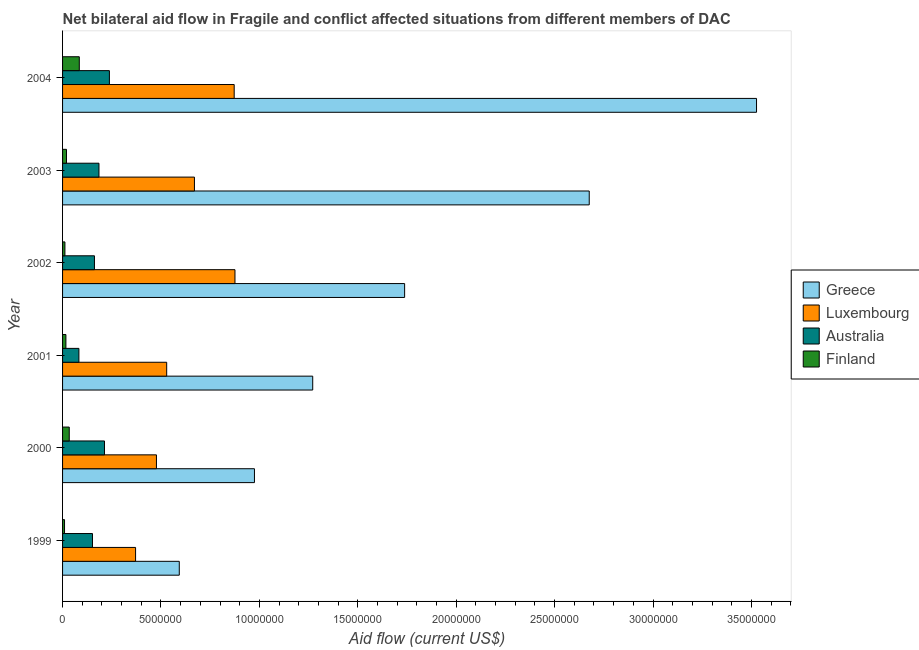How many groups of bars are there?
Offer a very short reply. 6. Are the number of bars on each tick of the Y-axis equal?
Keep it short and to the point. Yes. How many bars are there on the 1st tick from the top?
Provide a short and direct response. 4. How many bars are there on the 1st tick from the bottom?
Your answer should be compact. 4. What is the amount of aid given by australia in 2000?
Make the answer very short. 2.13e+06. Across all years, what is the maximum amount of aid given by greece?
Provide a short and direct response. 3.53e+07. Across all years, what is the minimum amount of aid given by greece?
Ensure brevity in your answer.  5.93e+06. In which year was the amount of aid given by luxembourg maximum?
Offer a very short reply. 2002. What is the total amount of aid given by greece in the graph?
Give a very brief answer. 1.08e+08. What is the difference between the amount of aid given by greece in 1999 and that in 2004?
Ensure brevity in your answer.  -2.93e+07. What is the difference between the amount of aid given by greece in 2004 and the amount of aid given by australia in 1999?
Make the answer very short. 3.37e+07. What is the average amount of aid given by greece per year?
Keep it short and to the point. 1.80e+07. In the year 1999, what is the difference between the amount of aid given by australia and amount of aid given by finland?
Provide a short and direct response. 1.42e+06. In how many years, is the amount of aid given by finland greater than 23000000 US$?
Your response must be concise. 0. What is the ratio of the amount of aid given by luxembourg in 1999 to that in 2004?
Provide a succinct answer. 0.42. What is the difference between the highest and the second highest amount of aid given by finland?
Your answer should be compact. 5.10e+05. What is the difference between the highest and the lowest amount of aid given by australia?
Your response must be concise. 1.55e+06. In how many years, is the amount of aid given by finland greater than the average amount of aid given by finland taken over all years?
Provide a succinct answer. 2. Is it the case that in every year, the sum of the amount of aid given by finland and amount of aid given by luxembourg is greater than the sum of amount of aid given by australia and amount of aid given by greece?
Your answer should be compact. Yes. What does the 1st bar from the bottom in 2004 represents?
Ensure brevity in your answer.  Greece. Is it the case that in every year, the sum of the amount of aid given by greece and amount of aid given by luxembourg is greater than the amount of aid given by australia?
Offer a terse response. Yes. How many years are there in the graph?
Keep it short and to the point. 6. Are the values on the major ticks of X-axis written in scientific E-notation?
Keep it short and to the point. No. Does the graph contain any zero values?
Ensure brevity in your answer.  No. Does the graph contain grids?
Offer a terse response. No. Where does the legend appear in the graph?
Your response must be concise. Center right. What is the title of the graph?
Make the answer very short. Net bilateral aid flow in Fragile and conflict affected situations from different members of DAC. What is the Aid flow (current US$) of Greece in 1999?
Your answer should be very brief. 5.93e+06. What is the Aid flow (current US$) in Luxembourg in 1999?
Your answer should be compact. 3.71e+06. What is the Aid flow (current US$) in Australia in 1999?
Your answer should be very brief. 1.52e+06. What is the Aid flow (current US$) in Greece in 2000?
Your response must be concise. 9.75e+06. What is the Aid flow (current US$) in Luxembourg in 2000?
Ensure brevity in your answer.  4.77e+06. What is the Aid flow (current US$) of Australia in 2000?
Provide a succinct answer. 2.13e+06. What is the Aid flow (current US$) of Greece in 2001?
Offer a very short reply. 1.27e+07. What is the Aid flow (current US$) in Luxembourg in 2001?
Keep it short and to the point. 5.29e+06. What is the Aid flow (current US$) of Australia in 2001?
Make the answer very short. 8.30e+05. What is the Aid flow (current US$) of Finland in 2001?
Keep it short and to the point. 1.70e+05. What is the Aid flow (current US$) of Greece in 2002?
Your response must be concise. 1.74e+07. What is the Aid flow (current US$) of Luxembourg in 2002?
Your answer should be compact. 8.76e+06. What is the Aid flow (current US$) of Australia in 2002?
Offer a very short reply. 1.62e+06. What is the Aid flow (current US$) of Finland in 2002?
Keep it short and to the point. 1.20e+05. What is the Aid flow (current US$) of Greece in 2003?
Make the answer very short. 2.68e+07. What is the Aid flow (current US$) in Luxembourg in 2003?
Your answer should be compact. 6.70e+06. What is the Aid flow (current US$) in Australia in 2003?
Make the answer very short. 1.85e+06. What is the Aid flow (current US$) in Finland in 2003?
Provide a short and direct response. 2.00e+05. What is the Aid flow (current US$) of Greece in 2004?
Keep it short and to the point. 3.53e+07. What is the Aid flow (current US$) of Luxembourg in 2004?
Keep it short and to the point. 8.72e+06. What is the Aid flow (current US$) in Australia in 2004?
Offer a terse response. 2.38e+06. What is the Aid flow (current US$) of Finland in 2004?
Provide a succinct answer. 8.50e+05. Across all years, what is the maximum Aid flow (current US$) in Greece?
Keep it short and to the point. 3.53e+07. Across all years, what is the maximum Aid flow (current US$) of Luxembourg?
Provide a short and direct response. 8.76e+06. Across all years, what is the maximum Aid flow (current US$) in Australia?
Offer a very short reply. 2.38e+06. Across all years, what is the maximum Aid flow (current US$) in Finland?
Offer a very short reply. 8.50e+05. Across all years, what is the minimum Aid flow (current US$) of Greece?
Your answer should be very brief. 5.93e+06. Across all years, what is the minimum Aid flow (current US$) of Luxembourg?
Make the answer very short. 3.71e+06. Across all years, what is the minimum Aid flow (current US$) in Australia?
Your response must be concise. 8.30e+05. Across all years, what is the minimum Aid flow (current US$) in Finland?
Provide a succinct answer. 1.00e+05. What is the total Aid flow (current US$) of Greece in the graph?
Ensure brevity in your answer.  1.08e+08. What is the total Aid flow (current US$) in Luxembourg in the graph?
Provide a short and direct response. 3.80e+07. What is the total Aid flow (current US$) in Australia in the graph?
Your answer should be very brief. 1.03e+07. What is the total Aid flow (current US$) in Finland in the graph?
Provide a short and direct response. 1.78e+06. What is the difference between the Aid flow (current US$) of Greece in 1999 and that in 2000?
Your answer should be compact. -3.82e+06. What is the difference between the Aid flow (current US$) in Luxembourg in 1999 and that in 2000?
Offer a terse response. -1.06e+06. What is the difference between the Aid flow (current US$) of Australia in 1999 and that in 2000?
Make the answer very short. -6.10e+05. What is the difference between the Aid flow (current US$) of Finland in 1999 and that in 2000?
Keep it short and to the point. -2.40e+05. What is the difference between the Aid flow (current US$) of Greece in 1999 and that in 2001?
Your answer should be compact. -6.78e+06. What is the difference between the Aid flow (current US$) in Luxembourg in 1999 and that in 2001?
Ensure brevity in your answer.  -1.58e+06. What is the difference between the Aid flow (current US$) in Australia in 1999 and that in 2001?
Offer a very short reply. 6.90e+05. What is the difference between the Aid flow (current US$) in Greece in 1999 and that in 2002?
Give a very brief answer. -1.14e+07. What is the difference between the Aid flow (current US$) of Luxembourg in 1999 and that in 2002?
Your answer should be very brief. -5.05e+06. What is the difference between the Aid flow (current US$) of Finland in 1999 and that in 2002?
Ensure brevity in your answer.  -2.00e+04. What is the difference between the Aid flow (current US$) of Greece in 1999 and that in 2003?
Provide a short and direct response. -2.08e+07. What is the difference between the Aid flow (current US$) in Luxembourg in 1999 and that in 2003?
Your answer should be compact. -2.99e+06. What is the difference between the Aid flow (current US$) of Australia in 1999 and that in 2003?
Ensure brevity in your answer.  -3.30e+05. What is the difference between the Aid flow (current US$) of Greece in 1999 and that in 2004?
Give a very brief answer. -2.93e+07. What is the difference between the Aid flow (current US$) of Luxembourg in 1999 and that in 2004?
Ensure brevity in your answer.  -5.01e+06. What is the difference between the Aid flow (current US$) in Australia in 1999 and that in 2004?
Provide a short and direct response. -8.60e+05. What is the difference between the Aid flow (current US$) in Finland in 1999 and that in 2004?
Your answer should be compact. -7.50e+05. What is the difference between the Aid flow (current US$) of Greece in 2000 and that in 2001?
Provide a succinct answer. -2.96e+06. What is the difference between the Aid flow (current US$) in Luxembourg in 2000 and that in 2001?
Keep it short and to the point. -5.20e+05. What is the difference between the Aid flow (current US$) of Australia in 2000 and that in 2001?
Make the answer very short. 1.30e+06. What is the difference between the Aid flow (current US$) in Finland in 2000 and that in 2001?
Your answer should be very brief. 1.70e+05. What is the difference between the Aid flow (current US$) of Greece in 2000 and that in 2002?
Offer a very short reply. -7.63e+06. What is the difference between the Aid flow (current US$) of Luxembourg in 2000 and that in 2002?
Your answer should be very brief. -3.99e+06. What is the difference between the Aid flow (current US$) in Australia in 2000 and that in 2002?
Provide a short and direct response. 5.10e+05. What is the difference between the Aid flow (current US$) in Greece in 2000 and that in 2003?
Offer a terse response. -1.70e+07. What is the difference between the Aid flow (current US$) of Luxembourg in 2000 and that in 2003?
Your response must be concise. -1.93e+06. What is the difference between the Aid flow (current US$) of Greece in 2000 and that in 2004?
Your answer should be compact. -2.55e+07. What is the difference between the Aid flow (current US$) of Luxembourg in 2000 and that in 2004?
Provide a succinct answer. -3.95e+06. What is the difference between the Aid flow (current US$) of Australia in 2000 and that in 2004?
Provide a succinct answer. -2.50e+05. What is the difference between the Aid flow (current US$) of Finland in 2000 and that in 2004?
Provide a succinct answer. -5.10e+05. What is the difference between the Aid flow (current US$) in Greece in 2001 and that in 2002?
Provide a short and direct response. -4.67e+06. What is the difference between the Aid flow (current US$) of Luxembourg in 2001 and that in 2002?
Offer a terse response. -3.47e+06. What is the difference between the Aid flow (current US$) of Australia in 2001 and that in 2002?
Your answer should be very brief. -7.90e+05. What is the difference between the Aid flow (current US$) in Greece in 2001 and that in 2003?
Offer a very short reply. -1.40e+07. What is the difference between the Aid flow (current US$) in Luxembourg in 2001 and that in 2003?
Your response must be concise. -1.41e+06. What is the difference between the Aid flow (current US$) in Australia in 2001 and that in 2003?
Provide a succinct answer. -1.02e+06. What is the difference between the Aid flow (current US$) of Finland in 2001 and that in 2003?
Your answer should be very brief. -3.00e+04. What is the difference between the Aid flow (current US$) in Greece in 2001 and that in 2004?
Offer a very short reply. -2.26e+07. What is the difference between the Aid flow (current US$) in Luxembourg in 2001 and that in 2004?
Keep it short and to the point. -3.43e+06. What is the difference between the Aid flow (current US$) in Australia in 2001 and that in 2004?
Provide a short and direct response. -1.55e+06. What is the difference between the Aid flow (current US$) of Finland in 2001 and that in 2004?
Give a very brief answer. -6.80e+05. What is the difference between the Aid flow (current US$) in Greece in 2002 and that in 2003?
Ensure brevity in your answer.  -9.38e+06. What is the difference between the Aid flow (current US$) of Luxembourg in 2002 and that in 2003?
Make the answer very short. 2.06e+06. What is the difference between the Aid flow (current US$) in Greece in 2002 and that in 2004?
Ensure brevity in your answer.  -1.79e+07. What is the difference between the Aid flow (current US$) in Australia in 2002 and that in 2004?
Offer a very short reply. -7.60e+05. What is the difference between the Aid flow (current US$) of Finland in 2002 and that in 2004?
Your answer should be very brief. -7.30e+05. What is the difference between the Aid flow (current US$) of Greece in 2003 and that in 2004?
Keep it short and to the point. -8.50e+06. What is the difference between the Aid flow (current US$) in Luxembourg in 2003 and that in 2004?
Give a very brief answer. -2.02e+06. What is the difference between the Aid flow (current US$) in Australia in 2003 and that in 2004?
Make the answer very short. -5.30e+05. What is the difference between the Aid flow (current US$) in Finland in 2003 and that in 2004?
Make the answer very short. -6.50e+05. What is the difference between the Aid flow (current US$) of Greece in 1999 and the Aid flow (current US$) of Luxembourg in 2000?
Provide a succinct answer. 1.16e+06. What is the difference between the Aid flow (current US$) of Greece in 1999 and the Aid flow (current US$) of Australia in 2000?
Provide a succinct answer. 3.80e+06. What is the difference between the Aid flow (current US$) in Greece in 1999 and the Aid flow (current US$) in Finland in 2000?
Ensure brevity in your answer.  5.59e+06. What is the difference between the Aid flow (current US$) of Luxembourg in 1999 and the Aid flow (current US$) of Australia in 2000?
Ensure brevity in your answer.  1.58e+06. What is the difference between the Aid flow (current US$) in Luxembourg in 1999 and the Aid flow (current US$) in Finland in 2000?
Offer a terse response. 3.37e+06. What is the difference between the Aid flow (current US$) of Australia in 1999 and the Aid flow (current US$) of Finland in 2000?
Ensure brevity in your answer.  1.18e+06. What is the difference between the Aid flow (current US$) of Greece in 1999 and the Aid flow (current US$) of Luxembourg in 2001?
Your response must be concise. 6.40e+05. What is the difference between the Aid flow (current US$) of Greece in 1999 and the Aid flow (current US$) of Australia in 2001?
Offer a very short reply. 5.10e+06. What is the difference between the Aid flow (current US$) in Greece in 1999 and the Aid flow (current US$) in Finland in 2001?
Give a very brief answer. 5.76e+06. What is the difference between the Aid flow (current US$) in Luxembourg in 1999 and the Aid flow (current US$) in Australia in 2001?
Provide a short and direct response. 2.88e+06. What is the difference between the Aid flow (current US$) in Luxembourg in 1999 and the Aid flow (current US$) in Finland in 2001?
Offer a terse response. 3.54e+06. What is the difference between the Aid flow (current US$) of Australia in 1999 and the Aid flow (current US$) of Finland in 2001?
Give a very brief answer. 1.35e+06. What is the difference between the Aid flow (current US$) in Greece in 1999 and the Aid flow (current US$) in Luxembourg in 2002?
Make the answer very short. -2.83e+06. What is the difference between the Aid flow (current US$) of Greece in 1999 and the Aid flow (current US$) of Australia in 2002?
Make the answer very short. 4.31e+06. What is the difference between the Aid flow (current US$) of Greece in 1999 and the Aid flow (current US$) of Finland in 2002?
Offer a very short reply. 5.81e+06. What is the difference between the Aid flow (current US$) of Luxembourg in 1999 and the Aid flow (current US$) of Australia in 2002?
Provide a succinct answer. 2.09e+06. What is the difference between the Aid flow (current US$) of Luxembourg in 1999 and the Aid flow (current US$) of Finland in 2002?
Make the answer very short. 3.59e+06. What is the difference between the Aid flow (current US$) of Australia in 1999 and the Aid flow (current US$) of Finland in 2002?
Your answer should be very brief. 1.40e+06. What is the difference between the Aid flow (current US$) in Greece in 1999 and the Aid flow (current US$) in Luxembourg in 2003?
Ensure brevity in your answer.  -7.70e+05. What is the difference between the Aid flow (current US$) of Greece in 1999 and the Aid flow (current US$) of Australia in 2003?
Offer a very short reply. 4.08e+06. What is the difference between the Aid flow (current US$) in Greece in 1999 and the Aid flow (current US$) in Finland in 2003?
Offer a terse response. 5.73e+06. What is the difference between the Aid flow (current US$) of Luxembourg in 1999 and the Aid flow (current US$) of Australia in 2003?
Provide a short and direct response. 1.86e+06. What is the difference between the Aid flow (current US$) in Luxembourg in 1999 and the Aid flow (current US$) in Finland in 2003?
Ensure brevity in your answer.  3.51e+06. What is the difference between the Aid flow (current US$) in Australia in 1999 and the Aid flow (current US$) in Finland in 2003?
Give a very brief answer. 1.32e+06. What is the difference between the Aid flow (current US$) of Greece in 1999 and the Aid flow (current US$) of Luxembourg in 2004?
Your answer should be very brief. -2.79e+06. What is the difference between the Aid flow (current US$) in Greece in 1999 and the Aid flow (current US$) in Australia in 2004?
Your answer should be very brief. 3.55e+06. What is the difference between the Aid flow (current US$) in Greece in 1999 and the Aid flow (current US$) in Finland in 2004?
Provide a succinct answer. 5.08e+06. What is the difference between the Aid flow (current US$) of Luxembourg in 1999 and the Aid flow (current US$) of Australia in 2004?
Your answer should be very brief. 1.33e+06. What is the difference between the Aid flow (current US$) of Luxembourg in 1999 and the Aid flow (current US$) of Finland in 2004?
Your response must be concise. 2.86e+06. What is the difference between the Aid flow (current US$) in Australia in 1999 and the Aid flow (current US$) in Finland in 2004?
Give a very brief answer. 6.70e+05. What is the difference between the Aid flow (current US$) in Greece in 2000 and the Aid flow (current US$) in Luxembourg in 2001?
Make the answer very short. 4.46e+06. What is the difference between the Aid flow (current US$) of Greece in 2000 and the Aid flow (current US$) of Australia in 2001?
Your answer should be compact. 8.92e+06. What is the difference between the Aid flow (current US$) of Greece in 2000 and the Aid flow (current US$) of Finland in 2001?
Your answer should be very brief. 9.58e+06. What is the difference between the Aid flow (current US$) of Luxembourg in 2000 and the Aid flow (current US$) of Australia in 2001?
Your response must be concise. 3.94e+06. What is the difference between the Aid flow (current US$) in Luxembourg in 2000 and the Aid flow (current US$) in Finland in 2001?
Make the answer very short. 4.60e+06. What is the difference between the Aid flow (current US$) in Australia in 2000 and the Aid flow (current US$) in Finland in 2001?
Give a very brief answer. 1.96e+06. What is the difference between the Aid flow (current US$) of Greece in 2000 and the Aid flow (current US$) of Luxembourg in 2002?
Keep it short and to the point. 9.90e+05. What is the difference between the Aid flow (current US$) of Greece in 2000 and the Aid flow (current US$) of Australia in 2002?
Provide a short and direct response. 8.13e+06. What is the difference between the Aid flow (current US$) of Greece in 2000 and the Aid flow (current US$) of Finland in 2002?
Keep it short and to the point. 9.63e+06. What is the difference between the Aid flow (current US$) of Luxembourg in 2000 and the Aid flow (current US$) of Australia in 2002?
Provide a succinct answer. 3.15e+06. What is the difference between the Aid flow (current US$) of Luxembourg in 2000 and the Aid flow (current US$) of Finland in 2002?
Offer a very short reply. 4.65e+06. What is the difference between the Aid flow (current US$) in Australia in 2000 and the Aid flow (current US$) in Finland in 2002?
Your answer should be compact. 2.01e+06. What is the difference between the Aid flow (current US$) in Greece in 2000 and the Aid flow (current US$) in Luxembourg in 2003?
Provide a short and direct response. 3.05e+06. What is the difference between the Aid flow (current US$) of Greece in 2000 and the Aid flow (current US$) of Australia in 2003?
Your answer should be compact. 7.90e+06. What is the difference between the Aid flow (current US$) of Greece in 2000 and the Aid flow (current US$) of Finland in 2003?
Provide a short and direct response. 9.55e+06. What is the difference between the Aid flow (current US$) of Luxembourg in 2000 and the Aid flow (current US$) of Australia in 2003?
Ensure brevity in your answer.  2.92e+06. What is the difference between the Aid flow (current US$) of Luxembourg in 2000 and the Aid flow (current US$) of Finland in 2003?
Ensure brevity in your answer.  4.57e+06. What is the difference between the Aid flow (current US$) in Australia in 2000 and the Aid flow (current US$) in Finland in 2003?
Your response must be concise. 1.93e+06. What is the difference between the Aid flow (current US$) of Greece in 2000 and the Aid flow (current US$) of Luxembourg in 2004?
Give a very brief answer. 1.03e+06. What is the difference between the Aid flow (current US$) of Greece in 2000 and the Aid flow (current US$) of Australia in 2004?
Provide a short and direct response. 7.37e+06. What is the difference between the Aid flow (current US$) in Greece in 2000 and the Aid flow (current US$) in Finland in 2004?
Make the answer very short. 8.90e+06. What is the difference between the Aid flow (current US$) of Luxembourg in 2000 and the Aid flow (current US$) of Australia in 2004?
Offer a terse response. 2.39e+06. What is the difference between the Aid flow (current US$) in Luxembourg in 2000 and the Aid flow (current US$) in Finland in 2004?
Provide a short and direct response. 3.92e+06. What is the difference between the Aid flow (current US$) of Australia in 2000 and the Aid flow (current US$) of Finland in 2004?
Offer a terse response. 1.28e+06. What is the difference between the Aid flow (current US$) of Greece in 2001 and the Aid flow (current US$) of Luxembourg in 2002?
Offer a terse response. 3.95e+06. What is the difference between the Aid flow (current US$) of Greece in 2001 and the Aid flow (current US$) of Australia in 2002?
Give a very brief answer. 1.11e+07. What is the difference between the Aid flow (current US$) of Greece in 2001 and the Aid flow (current US$) of Finland in 2002?
Offer a terse response. 1.26e+07. What is the difference between the Aid flow (current US$) of Luxembourg in 2001 and the Aid flow (current US$) of Australia in 2002?
Provide a short and direct response. 3.67e+06. What is the difference between the Aid flow (current US$) of Luxembourg in 2001 and the Aid flow (current US$) of Finland in 2002?
Keep it short and to the point. 5.17e+06. What is the difference between the Aid flow (current US$) of Australia in 2001 and the Aid flow (current US$) of Finland in 2002?
Your response must be concise. 7.10e+05. What is the difference between the Aid flow (current US$) of Greece in 2001 and the Aid flow (current US$) of Luxembourg in 2003?
Your answer should be very brief. 6.01e+06. What is the difference between the Aid flow (current US$) in Greece in 2001 and the Aid flow (current US$) in Australia in 2003?
Provide a short and direct response. 1.09e+07. What is the difference between the Aid flow (current US$) of Greece in 2001 and the Aid flow (current US$) of Finland in 2003?
Ensure brevity in your answer.  1.25e+07. What is the difference between the Aid flow (current US$) in Luxembourg in 2001 and the Aid flow (current US$) in Australia in 2003?
Ensure brevity in your answer.  3.44e+06. What is the difference between the Aid flow (current US$) of Luxembourg in 2001 and the Aid flow (current US$) of Finland in 2003?
Keep it short and to the point. 5.09e+06. What is the difference between the Aid flow (current US$) of Australia in 2001 and the Aid flow (current US$) of Finland in 2003?
Your answer should be very brief. 6.30e+05. What is the difference between the Aid flow (current US$) in Greece in 2001 and the Aid flow (current US$) in Luxembourg in 2004?
Provide a succinct answer. 3.99e+06. What is the difference between the Aid flow (current US$) in Greece in 2001 and the Aid flow (current US$) in Australia in 2004?
Offer a very short reply. 1.03e+07. What is the difference between the Aid flow (current US$) in Greece in 2001 and the Aid flow (current US$) in Finland in 2004?
Keep it short and to the point. 1.19e+07. What is the difference between the Aid flow (current US$) of Luxembourg in 2001 and the Aid flow (current US$) of Australia in 2004?
Give a very brief answer. 2.91e+06. What is the difference between the Aid flow (current US$) in Luxembourg in 2001 and the Aid flow (current US$) in Finland in 2004?
Provide a succinct answer. 4.44e+06. What is the difference between the Aid flow (current US$) of Australia in 2001 and the Aid flow (current US$) of Finland in 2004?
Give a very brief answer. -2.00e+04. What is the difference between the Aid flow (current US$) in Greece in 2002 and the Aid flow (current US$) in Luxembourg in 2003?
Ensure brevity in your answer.  1.07e+07. What is the difference between the Aid flow (current US$) in Greece in 2002 and the Aid flow (current US$) in Australia in 2003?
Your response must be concise. 1.55e+07. What is the difference between the Aid flow (current US$) of Greece in 2002 and the Aid flow (current US$) of Finland in 2003?
Keep it short and to the point. 1.72e+07. What is the difference between the Aid flow (current US$) of Luxembourg in 2002 and the Aid flow (current US$) of Australia in 2003?
Make the answer very short. 6.91e+06. What is the difference between the Aid flow (current US$) in Luxembourg in 2002 and the Aid flow (current US$) in Finland in 2003?
Make the answer very short. 8.56e+06. What is the difference between the Aid flow (current US$) of Australia in 2002 and the Aid flow (current US$) of Finland in 2003?
Provide a succinct answer. 1.42e+06. What is the difference between the Aid flow (current US$) in Greece in 2002 and the Aid flow (current US$) in Luxembourg in 2004?
Offer a terse response. 8.66e+06. What is the difference between the Aid flow (current US$) in Greece in 2002 and the Aid flow (current US$) in Australia in 2004?
Offer a terse response. 1.50e+07. What is the difference between the Aid flow (current US$) of Greece in 2002 and the Aid flow (current US$) of Finland in 2004?
Provide a succinct answer. 1.65e+07. What is the difference between the Aid flow (current US$) of Luxembourg in 2002 and the Aid flow (current US$) of Australia in 2004?
Ensure brevity in your answer.  6.38e+06. What is the difference between the Aid flow (current US$) in Luxembourg in 2002 and the Aid flow (current US$) in Finland in 2004?
Provide a short and direct response. 7.91e+06. What is the difference between the Aid flow (current US$) of Australia in 2002 and the Aid flow (current US$) of Finland in 2004?
Keep it short and to the point. 7.70e+05. What is the difference between the Aid flow (current US$) of Greece in 2003 and the Aid flow (current US$) of Luxembourg in 2004?
Make the answer very short. 1.80e+07. What is the difference between the Aid flow (current US$) of Greece in 2003 and the Aid flow (current US$) of Australia in 2004?
Keep it short and to the point. 2.44e+07. What is the difference between the Aid flow (current US$) in Greece in 2003 and the Aid flow (current US$) in Finland in 2004?
Offer a very short reply. 2.59e+07. What is the difference between the Aid flow (current US$) of Luxembourg in 2003 and the Aid flow (current US$) of Australia in 2004?
Your response must be concise. 4.32e+06. What is the difference between the Aid flow (current US$) in Luxembourg in 2003 and the Aid flow (current US$) in Finland in 2004?
Make the answer very short. 5.85e+06. What is the average Aid flow (current US$) of Greece per year?
Your answer should be compact. 1.80e+07. What is the average Aid flow (current US$) of Luxembourg per year?
Keep it short and to the point. 6.32e+06. What is the average Aid flow (current US$) in Australia per year?
Your answer should be very brief. 1.72e+06. What is the average Aid flow (current US$) of Finland per year?
Keep it short and to the point. 2.97e+05. In the year 1999, what is the difference between the Aid flow (current US$) in Greece and Aid flow (current US$) in Luxembourg?
Offer a terse response. 2.22e+06. In the year 1999, what is the difference between the Aid flow (current US$) in Greece and Aid flow (current US$) in Australia?
Offer a terse response. 4.41e+06. In the year 1999, what is the difference between the Aid flow (current US$) in Greece and Aid flow (current US$) in Finland?
Ensure brevity in your answer.  5.83e+06. In the year 1999, what is the difference between the Aid flow (current US$) of Luxembourg and Aid flow (current US$) of Australia?
Your answer should be very brief. 2.19e+06. In the year 1999, what is the difference between the Aid flow (current US$) of Luxembourg and Aid flow (current US$) of Finland?
Make the answer very short. 3.61e+06. In the year 1999, what is the difference between the Aid flow (current US$) in Australia and Aid flow (current US$) in Finland?
Your answer should be compact. 1.42e+06. In the year 2000, what is the difference between the Aid flow (current US$) of Greece and Aid flow (current US$) of Luxembourg?
Keep it short and to the point. 4.98e+06. In the year 2000, what is the difference between the Aid flow (current US$) of Greece and Aid flow (current US$) of Australia?
Make the answer very short. 7.62e+06. In the year 2000, what is the difference between the Aid flow (current US$) in Greece and Aid flow (current US$) in Finland?
Your answer should be compact. 9.41e+06. In the year 2000, what is the difference between the Aid flow (current US$) of Luxembourg and Aid flow (current US$) of Australia?
Provide a succinct answer. 2.64e+06. In the year 2000, what is the difference between the Aid flow (current US$) of Luxembourg and Aid flow (current US$) of Finland?
Offer a terse response. 4.43e+06. In the year 2000, what is the difference between the Aid flow (current US$) of Australia and Aid flow (current US$) of Finland?
Provide a short and direct response. 1.79e+06. In the year 2001, what is the difference between the Aid flow (current US$) of Greece and Aid flow (current US$) of Luxembourg?
Your response must be concise. 7.42e+06. In the year 2001, what is the difference between the Aid flow (current US$) in Greece and Aid flow (current US$) in Australia?
Make the answer very short. 1.19e+07. In the year 2001, what is the difference between the Aid flow (current US$) of Greece and Aid flow (current US$) of Finland?
Provide a succinct answer. 1.25e+07. In the year 2001, what is the difference between the Aid flow (current US$) in Luxembourg and Aid flow (current US$) in Australia?
Your response must be concise. 4.46e+06. In the year 2001, what is the difference between the Aid flow (current US$) in Luxembourg and Aid flow (current US$) in Finland?
Offer a terse response. 5.12e+06. In the year 2001, what is the difference between the Aid flow (current US$) of Australia and Aid flow (current US$) of Finland?
Offer a terse response. 6.60e+05. In the year 2002, what is the difference between the Aid flow (current US$) in Greece and Aid flow (current US$) in Luxembourg?
Your response must be concise. 8.62e+06. In the year 2002, what is the difference between the Aid flow (current US$) of Greece and Aid flow (current US$) of Australia?
Offer a very short reply. 1.58e+07. In the year 2002, what is the difference between the Aid flow (current US$) of Greece and Aid flow (current US$) of Finland?
Give a very brief answer. 1.73e+07. In the year 2002, what is the difference between the Aid flow (current US$) in Luxembourg and Aid flow (current US$) in Australia?
Your answer should be very brief. 7.14e+06. In the year 2002, what is the difference between the Aid flow (current US$) in Luxembourg and Aid flow (current US$) in Finland?
Keep it short and to the point. 8.64e+06. In the year 2002, what is the difference between the Aid flow (current US$) in Australia and Aid flow (current US$) in Finland?
Provide a short and direct response. 1.50e+06. In the year 2003, what is the difference between the Aid flow (current US$) of Greece and Aid flow (current US$) of Luxembourg?
Provide a succinct answer. 2.01e+07. In the year 2003, what is the difference between the Aid flow (current US$) of Greece and Aid flow (current US$) of Australia?
Keep it short and to the point. 2.49e+07. In the year 2003, what is the difference between the Aid flow (current US$) in Greece and Aid flow (current US$) in Finland?
Provide a short and direct response. 2.66e+07. In the year 2003, what is the difference between the Aid flow (current US$) in Luxembourg and Aid flow (current US$) in Australia?
Your answer should be compact. 4.85e+06. In the year 2003, what is the difference between the Aid flow (current US$) of Luxembourg and Aid flow (current US$) of Finland?
Your answer should be compact. 6.50e+06. In the year 2003, what is the difference between the Aid flow (current US$) in Australia and Aid flow (current US$) in Finland?
Offer a terse response. 1.65e+06. In the year 2004, what is the difference between the Aid flow (current US$) in Greece and Aid flow (current US$) in Luxembourg?
Make the answer very short. 2.65e+07. In the year 2004, what is the difference between the Aid flow (current US$) of Greece and Aid flow (current US$) of Australia?
Offer a terse response. 3.29e+07. In the year 2004, what is the difference between the Aid flow (current US$) of Greece and Aid flow (current US$) of Finland?
Keep it short and to the point. 3.44e+07. In the year 2004, what is the difference between the Aid flow (current US$) in Luxembourg and Aid flow (current US$) in Australia?
Make the answer very short. 6.34e+06. In the year 2004, what is the difference between the Aid flow (current US$) of Luxembourg and Aid flow (current US$) of Finland?
Provide a succinct answer. 7.87e+06. In the year 2004, what is the difference between the Aid flow (current US$) of Australia and Aid flow (current US$) of Finland?
Offer a very short reply. 1.53e+06. What is the ratio of the Aid flow (current US$) in Greece in 1999 to that in 2000?
Your answer should be compact. 0.61. What is the ratio of the Aid flow (current US$) of Australia in 1999 to that in 2000?
Your answer should be very brief. 0.71. What is the ratio of the Aid flow (current US$) in Finland in 1999 to that in 2000?
Offer a terse response. 0.29. What is the ratio of the Aid flow (current US$) in Greece in 1999 to that in 2001?
Keep it short and to the point. 0.47. What is the ratio of the Aid flow (current US$) of Luxembourg in 1999 to that in 2001?
Provide a succinct answer. 0.7. What is the ratio of the Aid flow (current US$) of Australia in 1999 to that in 2001?
Make the answer very short. 1.83. What is the ratio of the Aid flow (current US$) in Finland in 1999 to that in 2001?
Keep it short and to the point. 0.59. What is the ratio of the Aid flow (current US$) in Greece in 1999 to that in 2002?
Offer a terse response. 0.34. What is the ratio of the Aid flow (current US$) of Luxembourg in 1999 to that in 2002?
Provide a succinct answer. 0.42. What is the ratio of the Aid flow (current US$) in Australia in 1999 to that in 2002?
Keep it short and to the point. 0.94. What is the ratio of the Aid flow (current US$) in Greece in 1999 to that in 2003?
Your answer should be compact. 0.22. What is the ratio of the Aid flow (current US$) of Luxembourg in 1999 to that in 2003?
Your answer should be compact. 0.55. What is the ratio of the Aid flow (current US$) in Australia in 1999 to that in 2003?
Your response must be concise. 0.82. What is the ratio of the Aid flow (current US$) of Finland in 1999 to that in 2003?
Offer a very short reply. 0.5. What is the ratio of the Aid flow (current US$) in Greece in 1999 to that in 2004?
Provide a short and direct response. 0.17. What is the ratio of the Aid flow (current US$) in Luxembourg in 1999 to that in 2004?
Your answer should be compact. 0.43. What is the ratio of the Aid flow (current US$) in Australia in 1999 to that in 2004?
Your answer should be compact. 0.64. What is the ratio of the Aid flow (current US$) of Finland in 1999 to that in 2004?
Provide a succinct answer. 0.12. What is the ratio of the Aid flow (current US$) of Greece in 2000 to that in 2001?
Your answer should be compact. 0.77. What is the ratio of the Aid flow (current US$) in Luxembourg in 2000 to that in 2001?
Keep it short and to the point. 0.9. What is the ratio of the Aid flow (current US$) of Australia in 2000 to that in 2001?
Your response must be concise. 2.57. What is the ratio of the Aid flow (current US$) in Greece in 2000 to that in 2002?
Make the answer very short. 0.56. What is the ratio of the Aid flow (current US$) of Luxembourg in 2000 to that in 2002?
Your answer should be very brief. 0.54. What is the ratio of the Aid flow (current US$) in Australia in 2000 to that in 2002?
Provide a succinct answer. 1.31. What is the ratio of the Aid flow (current US$) in Finland in 2000 to that in 2002?
Your answer should be compact. 2.83. What is the ratio of the Aid flow (current US$) in Greece in 2000 to that in 2003?
Offer a terse response. 0.36. What is the ratio of the Aid flow (current US$) in Luxembourg in 2000 to that in 2003?
Make the answer very short. 0.71. What is the ratio of the Aid flow (current US$) of Australia in 2000 to that in 2003?
Your answer should be compact. 1.15. What is the ratio of the Aid flow (current US$) of Finland in 2000 to that in 2003?
Give a very brief answer. 1.7. What is the ratio of the Aid flow (current US$) of Greece in 2000 to that in 2004?
Provide a short and direct response. 0.28. What is the ratio of the Aid flow (current US$) of Luxembourg in 2000 to that in 2004?
Offer a very short reply. 0.55. What is the ratio of the Aid flow (current US$) in Australia in 2000 to that in 2004?
Keep it short and to the point. 0.9. What is the ratio of the Aid flow (current US$) in Finland in 2000 to that in 2004?
Offer a terse response. 0.4. What is the ratio of the Aid flow (current US$) of Greece in 2001 to that in 2002?
Provide a succinct answer. 0.73. What is the ratio of the Aid flow (current US$) in Luxembourg in 2001 to that in 2002?
Offer a very short reply. 0.6. What is the ratio of the Aid flow (current US$) in Australia in 2001 to that in 2002?
Provide a short and direct response. 0.51. What is the ratio of the Aid flow (current US$) of Finland in 2001 to that in 2002?
Your answer should be compact. 1.42. What is the ratio of the Aid flow (current US$) in Greece in 2001 to that in 2003?
Make the answer very short. 0.47. What is the ratio of the Aid flow (current US$) of Luxembourg in 2001 to that in 2003?
Offer a terse response. 0.79. What is the ratio of the Aid flow (current US$) of Australia in 2001 to that in 2003?
Provide a short and direct response. 0.45. What is the ratio of the Aid flow (current US$) of Greece in 2001 to that in 2004?
Offer a terse response. 0.36. What is the ratio of the Aid flow (current US$) in Luxembourg in 2001 to that in 2004?
Your answer should be compact. 0.61. What is the ratio of the Aid flow (current US$) of Australia in 2001 to that in 2004?
Keep it short and to the point. 0.35. What is the ratio of the Aid flow (current US$) in Finland in 2001 to that in 2004?
Ensure brevity in your answer.  0.2. What is the ratio of the Aid flow (current US$) of Greece in 2002 to that in 2003?
Your response must be concise. 0.65. What is the ratio of the Aid flow (current US$) in Luxembourg in 2002 to that in 2003?
Provide a short and direct response. 1.31. What is the ratio of the Aid flow (current US$) of Australia in 2002 to that in 2003?
Give a very brief answer. 0.88. What is the ratio of the Aid flow (current US$) of Greece in 2002 to that in 2004?
Offer a terse response. 0.49. What is the ratio of the Aid flow (current US$) in Australia in 2002 to that in 2004?
Ensure brevity in your answer.  0.68. What is the ratio of the Aid flow (current US$) in Finland in 2002 to that in 2004?
Your response must be concise. 0.14. What is the ratio of the Aid flow (current US$) of Greece in 2003 to that in 2004?
Your answer should be very brief. 0.76. What is the ratio of the Aid flow (current US$) in Luxembourg in 2003 to that in 2004?
Provide a short and direct response. 0.77. What is the ratio of the Aid flow (current US$) of Australia in 2003 to that in 2004?
Ensure brevity in your answer.  0.78. What is the ratio of the Aid flow (current US$) of Finland in 2003 to that in 2004?
Offer a terse response. 0.24. What is the difference between the highest and the second highest Aid flow (current US$) of Greece?
Give a very brief answer. 8.50e+06. What is the difference between the highest and the second highest Aid flow (current US$) of Luxembourg?
Make the answer very short. 4.00e+04. What is the difference between the highest and the second highest Aid flow (current US$) of Australia?
Your answer should be very brief. 2.50e+05. What is the difference between the highest and the second highest Aid flow (current US$) of Finland?
Your answer should be compact. 5.10e+05. What is the difference between the highest and the lowest Aid flow (current US$) of Greece?
Make the answer very short. 2.93e+07. What is the difference between the highest and the lowest Aid flow (current US$) in Luxembourg?
Make the answer very short. 5.05e+06. What is the difference between the highest and the lowest Aid flow (current US$) of Australia?
Keep it short and to the point. 1.55e+06. What is the difference between the highest and the lowest Aid flow (current US$) in Finland?
Your answer should be compact. 7.50e+05. 